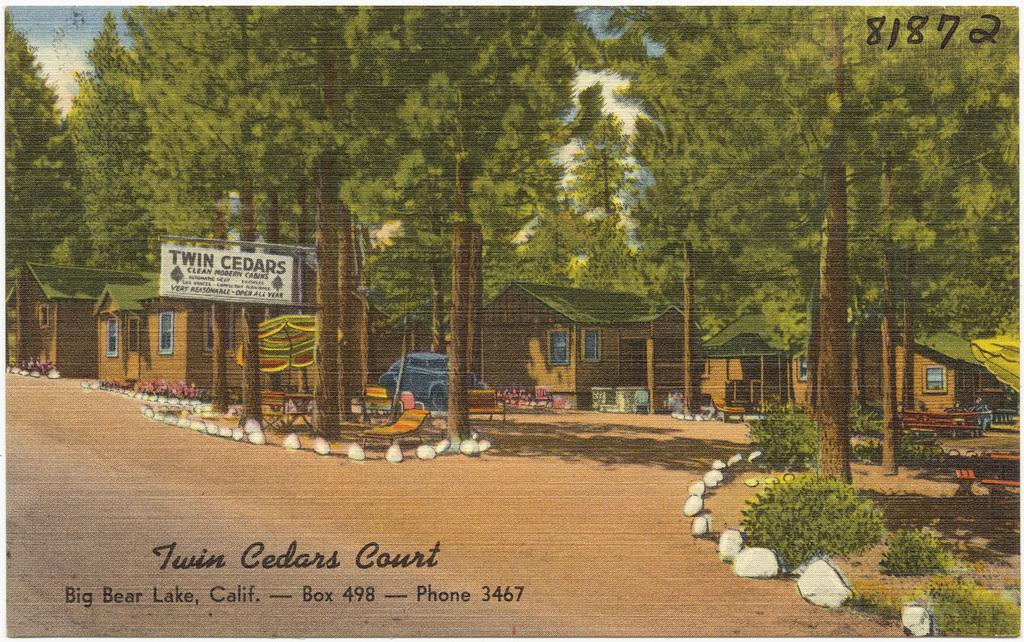What type of structures can be seen in the image? There are houses in the image. What other objects can be seen in the image besides houses? There are trees, windows, a table, a blue car, umbrellas on the road, and a white color signboard in the image. What is the color of the sky in the image? The sky is blue and white in color. What type of blade is being used to act in the house in the image? There is no blade or act being performed in the image; it simply shows houses, trees, windows, a table, a blue car, umbrellas on the road, and a white color signboard. 